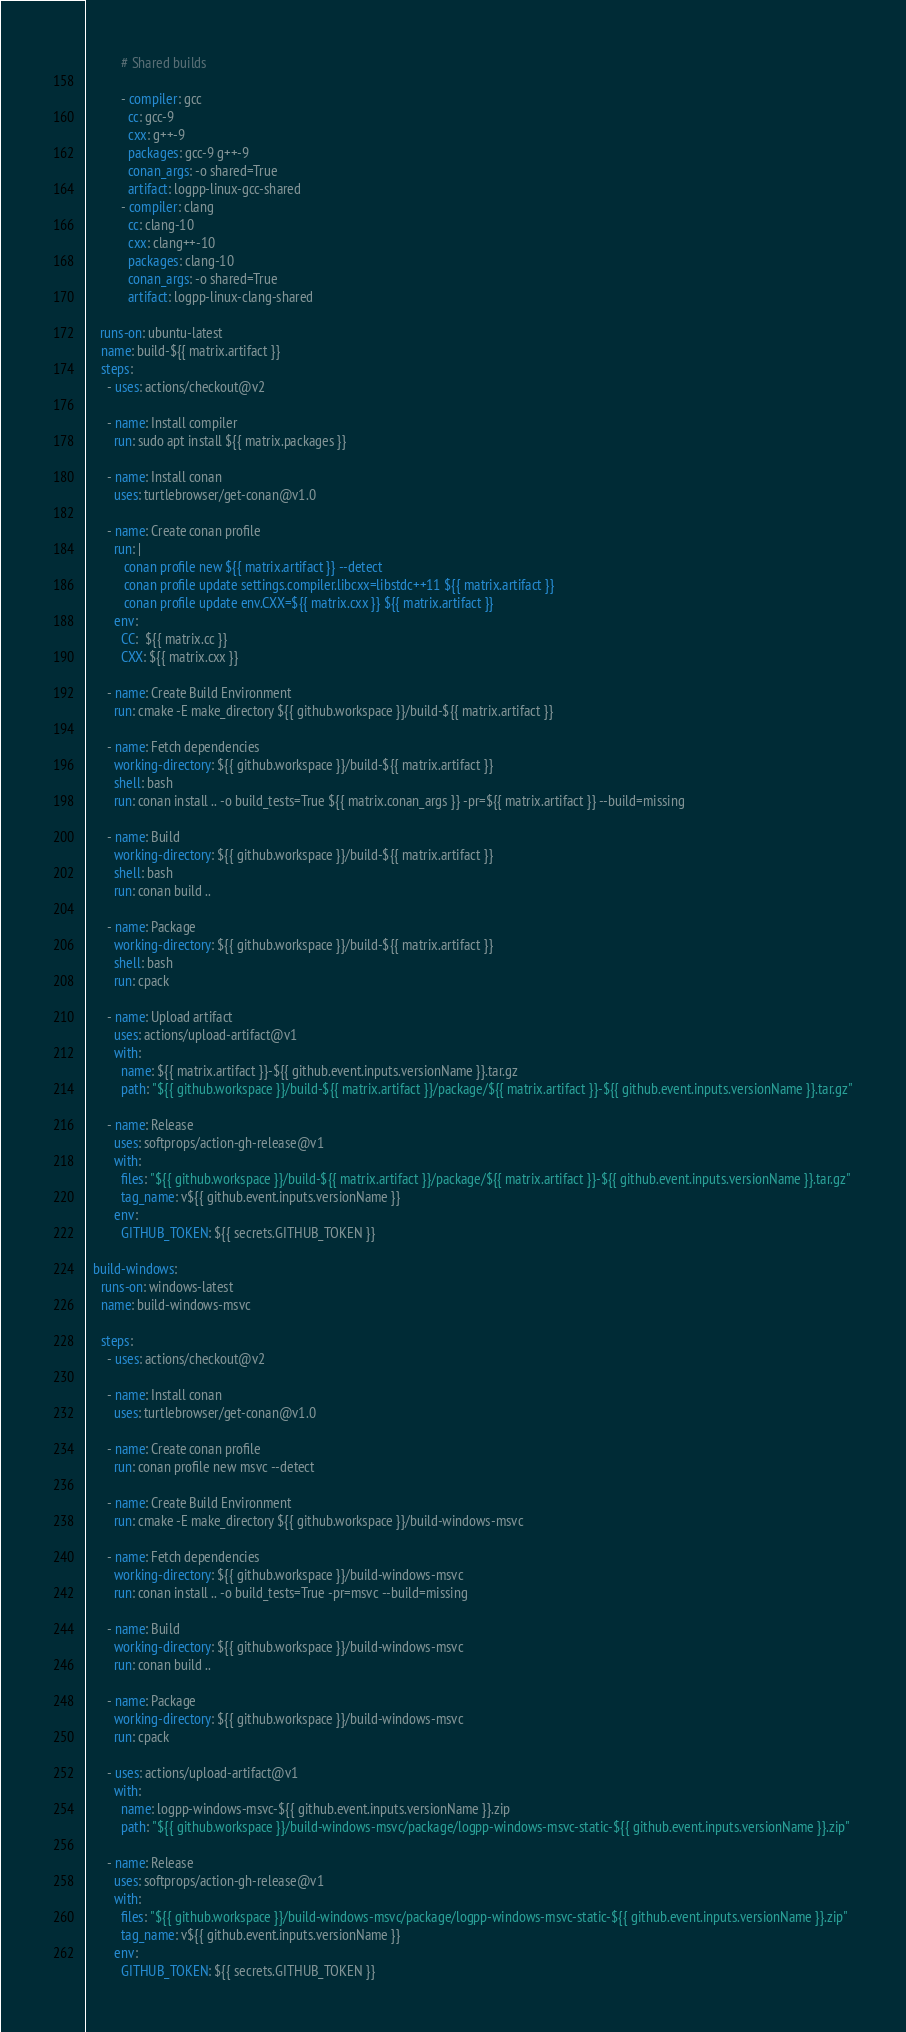<code> <loc_0><loc_0><loc_500><loc_500><_YAML_>
          # Shared builds

          - compiler: gcc
            cc: gcc-9
            cxx: g++-9
            packages: gcc-9 g++-9
            conan_args: -o shared=True
            artifact: logpp-linux-gcc-shared
          - compiler: clang
            cc: clang-10
            cxx: clang++-10
            packages: clang-10
            conan_args: -o shared=True
            artifact: logpp-linux-clang-shared

    runs-on: ubuntu-latest
    name: build-${{ matrix.artifact }}
    steps:
      - uses: actions/checkout@v2

      - name: Install compiler
        run: sudo apt install ${{ matrix.packages }}

      - name: Install conan
        uses: turtlebrowser/get-conan@v1.0

      - name: Create conan profile
        run: |
           conan profile new ${{ matrix.artifact }} --detect
           conan profile update settings.compiler.libcxx=libstdc++11 ${{ matrix.artifact }}
           conan profile update env.CXX=${{ matrix.cxx }} ${{ matrix.artifact }}
        env:
          CC:  ${{ matrix.cc }}
          CXX: ${{ matrix.cxx }}

      - name: Create Build Environment
        run: cmake -E make_directory ${{ github.workspace }}/build-${{ matrix.artifact }}

      - name: Fetch dependencies
        working-directory: ${{ github.workspace }}/build-${{ matrix.artifact }}
        shell: bash
        run: conan install .. -o build_tests=True ${{ matrix.conan_args }} -pr=${{ matrix.artifact }} --build=missing

      - name: Build
        working-directory: ${{ github.workspace }}/build-${{ matrix.artifact }}
        shell: bash
        run: conan build ..

      - name: Package
        working-directory: ${{ github.workspace }}/build-${{ matrix.artifact }}
        shell: bash
        run: cpack

      - name: Upload artifact
        uses: actions/upload-artifact@v1
        with:
          name: ${{ matrix.artifact }}-${{ github.event.inputs.versionName }}.tar.gz
          path: "${{ github.workspace }}/build-${{ matrix.artifact }}/package/${{ matrix.artifact }}-${{ github.event.inputs.versionName }}.tar.gz"

      - name: Release
        uses: softprops/action-gh-release@v1
        with:
          files: "${{ github.workspace }}/build-${{ matrix.artifact }}/package/${{ matrix.artifact }}-${{ github.event.inputs.versionName }}.tar.gz"
          tag_name: v${{ github.event.inputs.versionName }}
        env:
          GITHUB_TOKEN: ${{ secrets.GITHUB_TOKEN }}

  build-windows:
    runs-on: windows-latest
    name: build-windows-msvc

    steps:
      - uses: actions/checkout@v2

      - name: Install conan
        uses: turtlebrowser/get-conan@v1.0

      - name: Create conan profile
        run: conan profile new msvc --detect

      - name: Create Build Environment
        run: cmake -E make_directory ${{ github.workspace }}/build-windows-msvc

      - name: Fetch dependencies
        working-directory: ${{ github.workspace }}/build-windows-msvc
        run: conan install .. -o build_tests=True -pr=msvc --build=missing

      - name: Build
        working-directory: ${{ github.workspace }}/build-windows-msvc
        run: conan build ..

      - name: Package
        working-directory: ${{ github.workspace }}/build-windows-msvc
        run: cpack

      - uses: actions/upload-artifact@v1
        with:
          name: logpp-windows-msvc-${{ github.event.inputs.versionName }}.zip
          path: "${{ github.workspace }}/build-windows-msvc/package/logpp-windows-msvc-static-${{ github.event.inputs.versionName }}.zip"

      - name: Release
        uses: softprops/action-gh-release@v1
        with:
          files: "${{ github.workspace }}/build-windows-msvc/package/logpp-windows-msvc-static-${{ github.event.inputs.versionName }}.zip"
          tag_name: v${{ github.event.inputs.versionName }}
        env:
          GITHUB_TOKEN: ${{ secrets.GITHUB_TOKEN }}
</code> 